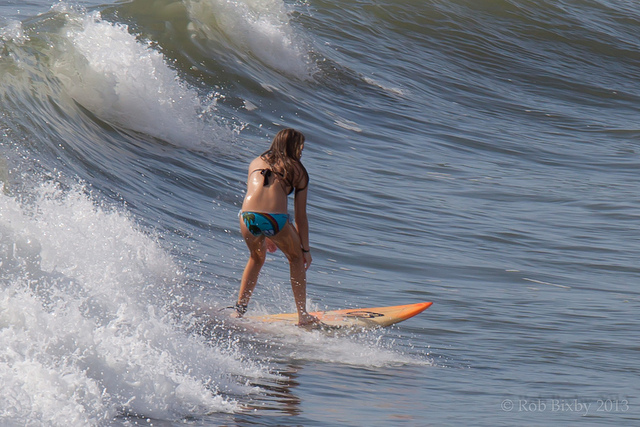Read and extract the text from this image. Bixby 2013 Rob c 